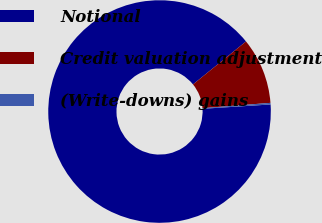Convert chart. <chart><loc_0><loc_0><loc_500><loc_500><pie_chart><fcel>Notional<fcel>Credit valuation adjustment<fcel>(Write-downs) gains<nl><fcel>90.18%<fcel>9.6%<fcel>0.23%<nl></chart> 